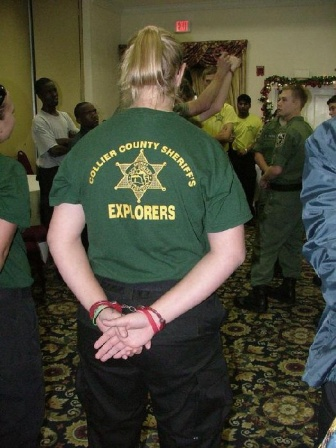Considering the festive decorations, what do you think this group is celebrating? Based on the garlands and Christmas decorations seen in the image, it appears that the Collier County Sheriff's Explorers are celebrating a holiday event, most likely Christmas. This festive setting suggests that the group has come together to celebrate the season, enjoy each other's company, and possibly spread holiday cheer within the community. Such celebrations often include activities like singing carols, exchanging gifts, sharing a festive meal, and reflecting on the year’s achievements. The event is likely not just about festivities but also reinforcing the bonds within this community-oriented group. 